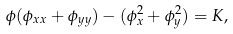<formula> <loc_0><loc_0><loc_500><loc_500>\phi ( \phi _ { x x } + \phi _ { y y } ) - ( \phi _ { x } ^ { 2 } + \phi _ { y } ^ { 2 } ) = K ,</formula> 